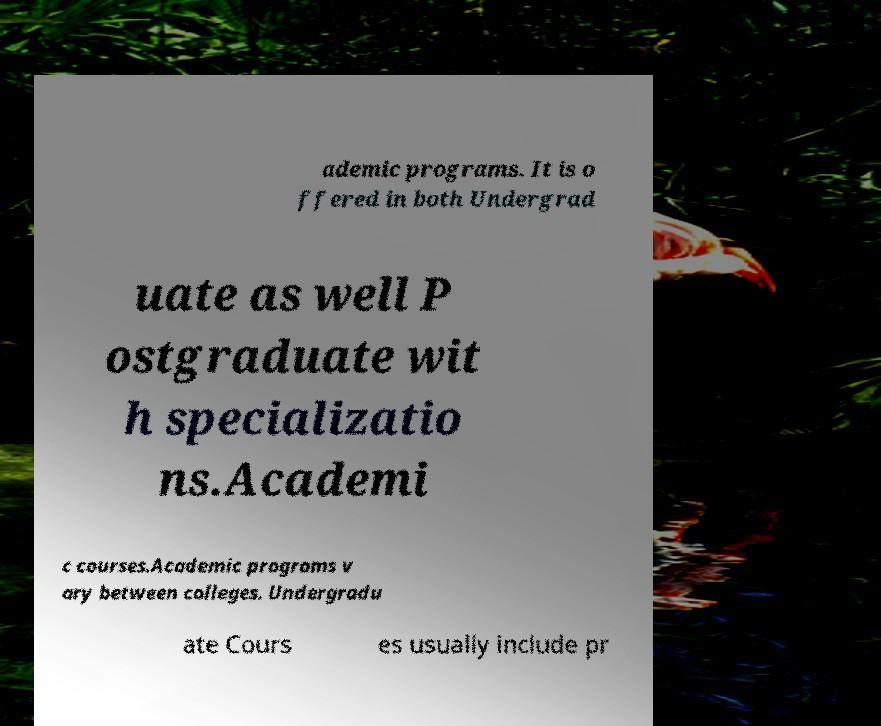Could you assist in decoding the text presented in this image and type it out clearly? ademic programs. It is o ffered in both Undergrad uate as well P ostgraduate wit h specializatio ns.Academi c courses.Academic programs v ary between colleges. Undergradu ate Cours es usually include pr 